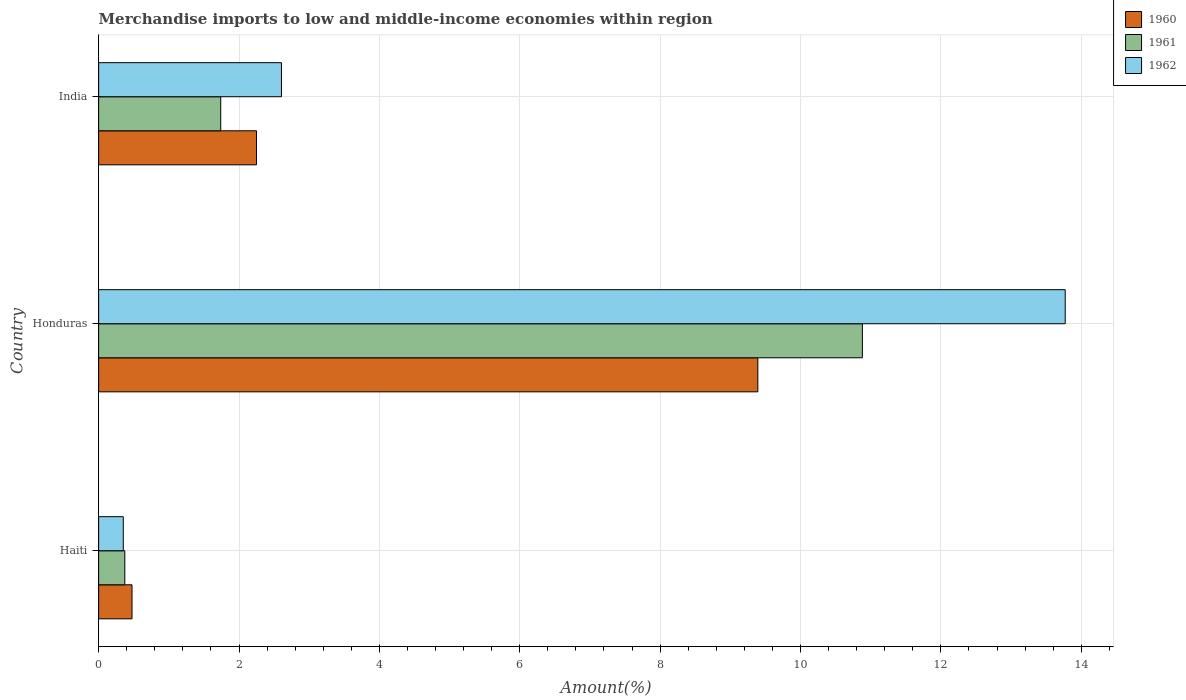How many groups of bars are there?
Ensure brevity in your answer.  3. How many bars are there on the 3rd tick from the top?
Your answer should be very brief. 3. How many bars are there on the 1st tick from the bottom?
Your answer should be very brief. 3. What is the label of the 2nd group of bars from the top?
Your response must be concise. Honduras. In how many cases, is the number of bars for a given country not equal to the number of legend labels?
Your answer should be very brief. 0. What is the percentage of amount earned from merchandise imports in 1961 in India?
Make the answer very short. 1.74. Across all countries, what is the maximum percentage of amount earned from merchandise imports in 1960?
Keep it short and to the point. 9.39. Across all countries, what is the minimum percentage of amount earned from merchandise imports in 1960?
Your answer should be very brief. 0.48. In which country was the percentage of amount earned from merchandise imports in 1962 maximum?
Ensure brevity in your answer.  Honduras. In which country was the percentage of amount earned from merchandise imports in 1961 minimum?
Your answer should be compact. Haiti. What is the total percentage of amount earned from merchandise imports in 1962 in the graph?
Give a very brief answer. 16.73. What is the difference between the percentage of amount earned from merchandise imports in 1961 in Haiti and that in Honduras?
Ensure brevity in your answer.  -10.51. What is the difference between the percentage of amount earned from merchandise imports in 1962 in Honduras and the percentage of amount earned from merchandise imports in 1961 in Haiti?
Your response must be concise. 13.4. What is the average percentage of amount earned from merchandise imports in 1960 per country?
Ensure brevity in your answer.  4.04. What is the difference between the percentage of amount earned from merchandise imports in 1960 and percentage of amount earned from merchandise imports in 1961 in Honduras?
Make the answer very short. -1.49. In how many countries, is the percentage of amount earned from merchandise imports in 1962 greater than 0.8 %?
Your answer should be compact. 2. What is the ratio of the percentage of amount earned from merchandise imports in 1960 in Haiti to that in India?
Provide a succinct answer. 0.21. Is the difference between the percentage of amount earned from merchandise imports in 1960 in Haiti and India greater than the difference between the percentage of amount earned from merchandise imports in 1961 in Haiti and India?
Give a very brief answer. No. What is the difference between the highest and the second highest percentage of amount earned from merchandise imports in 1962?
Offer a very short reply. 11.17. What is the difference between the highest and the lowest percentage of amount earned from merchandise imports in 1960?
Provide a succinct answer. 8.92. In how many countries, is the percentage of amount earned from merchandise imports in 1960 greater than the average percentage of amount earned from merchandise imports in 1960 taken over all countries?
Provide a succinct answer. 1. What does the 3rd bar from the top in Haiti represents?
Keep it short and to the point. 1960. Are all the bars in the graph horizontal?
Make the answer very short. Yes. Are the values on the major ticks of X-axis written in scientific E-notation?
Provide a succinct answer. No. Does the graph contain any zero values?
Offer a very short reply. No. What is the title of the graph?
Keep it short and to the point. Merchandise imports to low and middle-income economies within region. What is the label or title of the X-axis?
Make the answer very short. Amount(%). What is the Amount(%) of 1960 in Haiti?
Offer a very short reply. 0.48. What is the Amount(%) of 1961 in Haiti?
Provide a succinct answer. 0.37. What is the Amount(%) in 1962 in Haiti?
Provide a succinct answer. 0.35. What is the Amount(%) of 1960 in Honduras?
Keep it short and to the point. 9.39. What is the Amount(%) in 1961 in Honduras?
Give a very brief answer. 10.88. What is the Amount(%) of 1962 in Honduras?
Offer a terse response. 13.77. What is the Amount(%) of 1960 in India?
Your answer should be compact. 2.25. What is the Amount(%) in 1961 in India?
Provide a short and direct response. 1.74. What is the Amount(%) in 1962 in India?
Offer a terse response. 2.6. Across all countries, what is the maximum Amount(%) of 1960?
Make the answer very short. 9.39. Across all countries, what is the maximum Amount(%) in 1961?
Offer a terse response. 10.88. Across all countries, what is the maximum Amount(%) of 1962?
Make the answer very short. 13.77. Across all countries, what is the minimum Amount(%) of 1960?
Offer a terse response. 0.48. Across all countries, what is the minimum Amount(%) of 1961?
Provide a succinct answer. 0.37. Across all countries, what is the minimum Amount(%) in 1962?
Keep it short and to the point. 0.35. What is the total Amount(%) in 1960 in the graph?
Offer a terse response. 12.12. What is the total Amount(%) in 1961 in the graph?
Make the answer very short. 12.99. What is the total Amount(%) of 1962 in the graph?
Your answer should be compact. 16.73. What is the difference between the Amount(%) in 1960 in Haiti and that in Honduras?
Offer a very short reply. -8.92. What is the difference between the Amount(%) of 1961 in Haiti and that in Honduras?
Your answer should be very brief. -10.51. What is the difference between the Amount(%) in 1962 in Haiti and that in Honduras?
Your answer should be compact. -13.42. What is the difference between the Amount(%) of 1960 in Haiti and that in India?
Provide a succinct answer. -1.77. What is the difference between the Amount(%) in 1961 in Haiti and that in India?
Keep it short and to the point. -1.37. What is the difference between the Amount(%) of 1962 in Haiti and that in India?
Keep it short and to the point. -2.25. What is the difference between the Amount(%) of 1960 in Honduras and that in India?
Keep it short and to the point. 7.14. What is the difference between the Amount(%) in 1961 in Honduras and that in India?
Make the answer very short. 9.14. What is the difference between the Amount(%) of 1962 in Honduras and that in India?
Provide a short and direct response. 11.17. What is the difference between the Amount(%) of 1960 in Haiti and the Amount(%) of 1961 in Honduras?
Give a very brief answer. -10.41. What is the difference between the Amount(%) in 1960 in Haiti and the Amount(%) in 1962 in Honduras?
Provide a short and direct response. -13.3. What is the difference between the Amount(%) in 1961 in Haiti and the Amount(%) in 1962 in Honduras?
Give a very brief answer. -13.4. What is the difference between the Amount(%) of 1960 in Haiti and the Amount(%) of 1961 in India?
Make the answer very short. -1.26. What is the difference between the Amount(%) in 1960 in Haiti and the Amount(%) in 1962 in India?
Offer a very short reply. -2.13. What is the difference between the Amount(%) of 1961 in Haiti and the Amount(%) of 1962 in India?
Your response must be concise. -2.23. What is the difference between the Amount(%) in 1960 in Honduras and the Amount(%) in 1961 in India?
Your answer should be compact. 7.65. What is the difference between the Amount(%) in 1960 in Honduras and the Amount(%) in 1962 in India?
Give a very brief answer. 6.79. What is the difference between the Amount(%) of 1961 in Honduras and the Amount(%) of 1962 in India?
Offer a terse response. 8.28. What is the average Amount(%) of 1960 per country?
Your answer should be compact. 4.04. What is the average Amount(%) in 1961 per country?
Offer a very short reply. 4.33. What is the average Amount(%) in 1962 per country?
Keep it short and to the point. 5.58. What is the difference between the Amount(%) in 1960 and Amount(%) in 1961 in Haiti?
Provide a short and direct response. 0.1. What is the difference between the Amount(%) of 1960 and Amount(%) of 1962 in Haiti?
Your response must be concise. 0.12. What is the difference between the Amount(%) in 1961 and Amount(%) in 1962 in Haiti?
Ensure brevity in your answer.  0.02. What is the difference between the Amount(%) of 1960 and Amount(%) of 1961 in Honduras?
Make the answer very short. -1.49. What is the difference between the Amount(%) in 1960 and Amount(%) in 1962 in Honduras?
Make the answer very short. -4.38. What is the difference between the Amount(%) of 1961 and Amount(%) of 1962 in Honduras?
Provide a short and direct response. -2.89. What is the difference between the Amount(%) of 1960 and Amount(%) of 1961 in India?
Provide a succinct answer. 0.51. What is the difference between the Amount(%) of 1960 and Amount(%) of 1962 in India?
Provide a succinct answer. -0.36. What is the difference between the Amount(%) of 1961 and Amount(%) of 1962 in India?
Offer a terse response. -0.87. What is the ratio of the Amount(%) in 1960 in Haiti to that in Honduras?
Make the answer very short. 0.05. What is the ratio of the Amount(%) in 1961 in Haiti to that in Honduras?
Give a very brief answer. 0.03. What is the ratio of the Amount(%) in 1962 in Haiti to that in Honduras?
Ensure brevity in your answer.  0.03. What is the ratio of the Amount(%) in 1960 in Haiti to that in India?
Your answer should be compact. 0.21. What is the ratio of the Amount(%) of 1961 in Haiti to that in India?
Provide a short and direct response. 0.21. What is the ratio of the Amount(%) of 1962 in Haiti to that in India?
Your answer should be very brief. 0.13. What is the ratio of the Amount(%) of 1960 in Honduras to that in India?
Offer a very short reply. 4.18. What is the ratio of the Amount(%) of 1961 in Honduras to that in India?
Keep it short and to the point. 6.26. What is the ratio of the Amount(%) in 1962 in Honduras to that in India?
Provide a short and direct response. 5.29. What is the difference between the highest and the second highest Amount(%) in 1960?
Give a very brief answer. 7.14. What is the difference between the highest and the second highest Amount(%) of 1961?
Your answer should be very brief. 9.14. What is the difference between the highest and the second highest Amount(%) of 1962?
Your answer should be very brief. 11.17. What is the difference between the highest and the lowest Amount(%) of 1960?
Offer a terse response. 8.92. What is the difference between the highest and the lowest Amount(%) of 1961?
Make the answer very short. 10.51. What is the difference between the highest and the lowest Amount(%) of 1962?
Offer a very short reply. 13.42. 